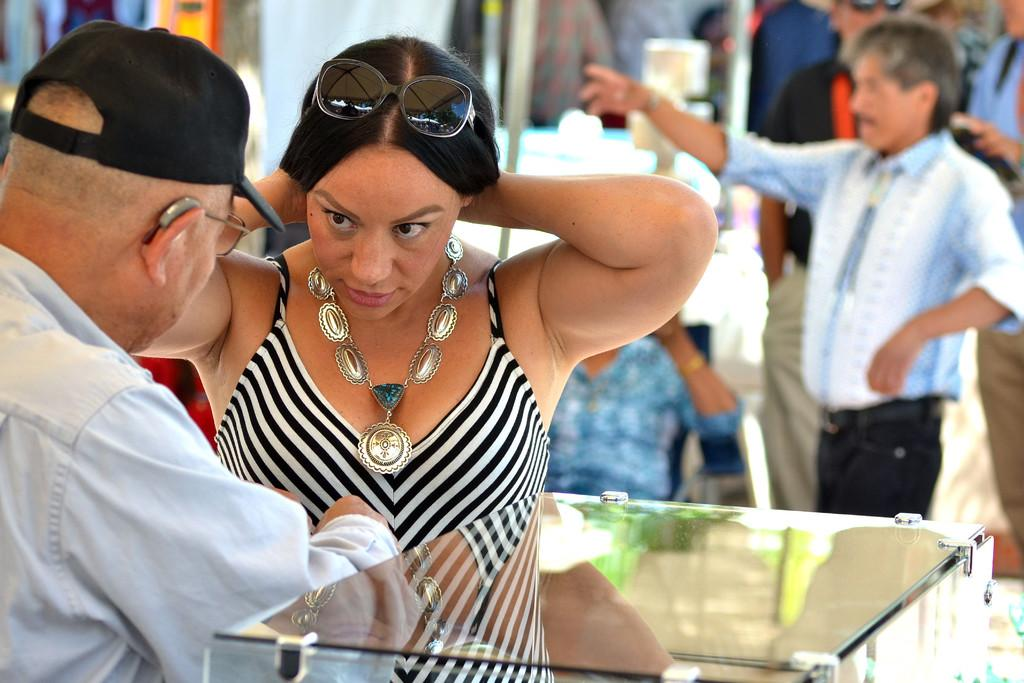Who can be seen in the image? There are people in the image. Can you describe the woman in the image? The woman in the image is wearing an ornament. What can be observed about the background of the image? The background of the image is blurry. What type of stove is being used for the distribution of the statement in the image? There is no stove, distribution, or statement present in the image. 